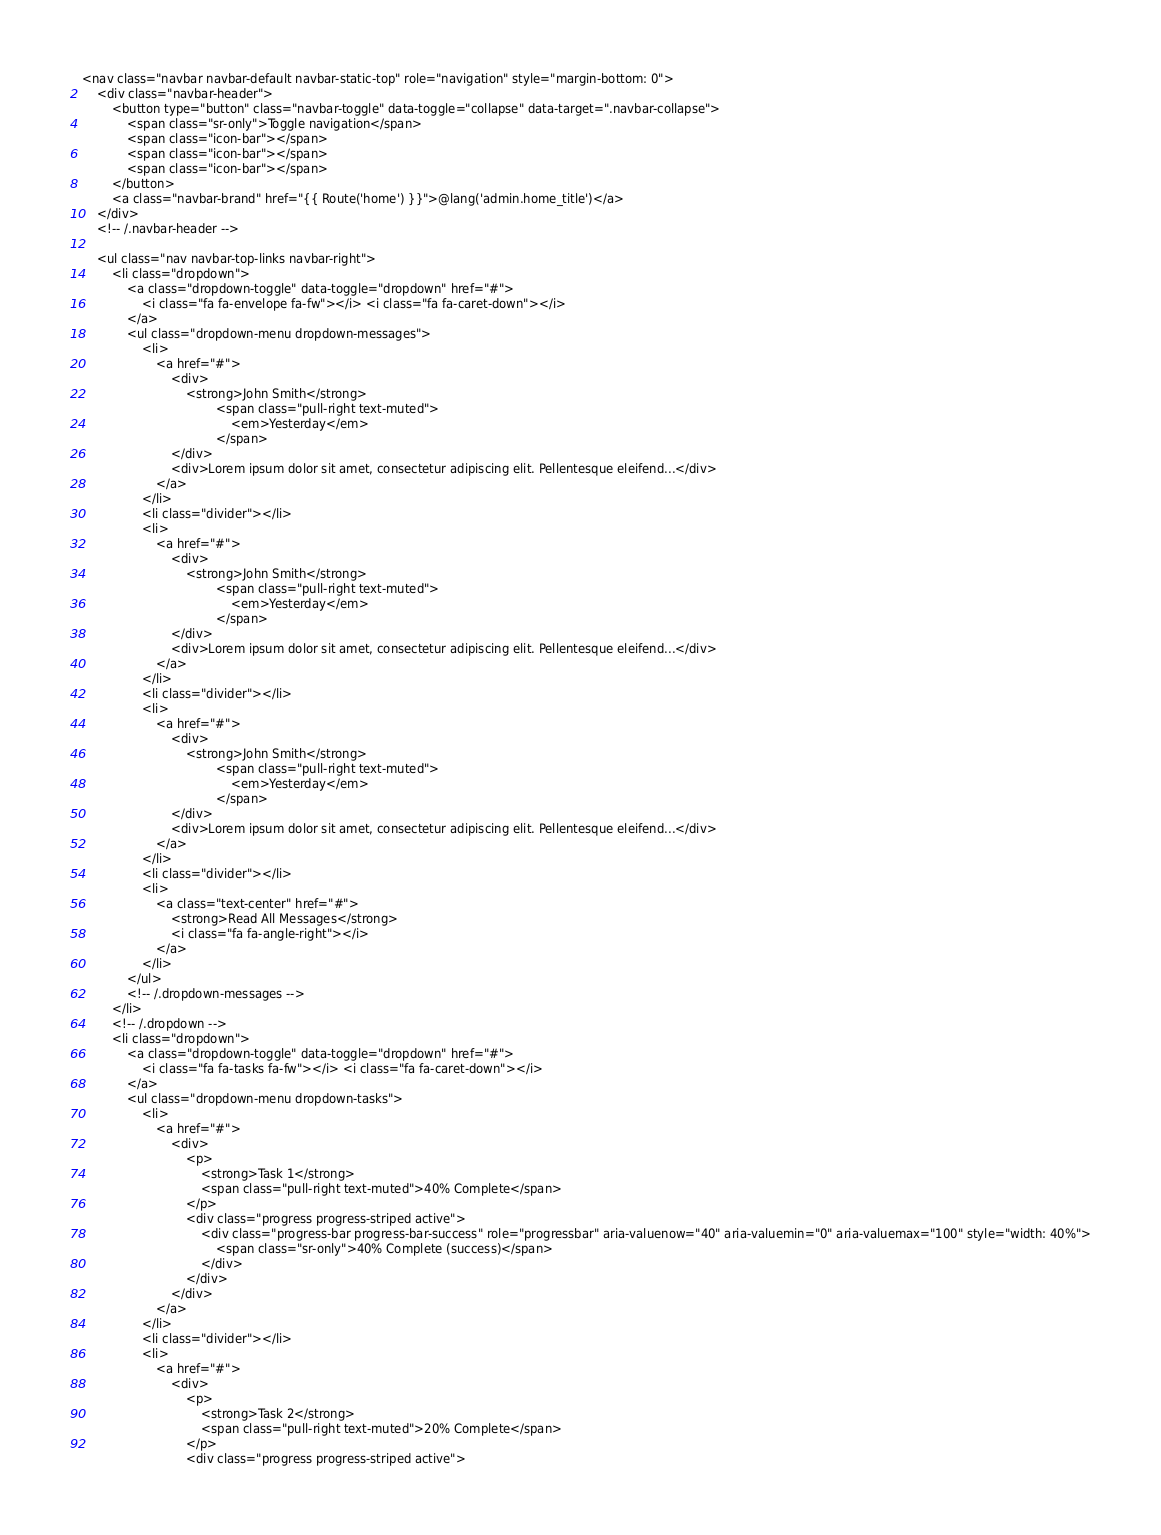<code> <loc_0><loc_0><loc_500><loc_500><_PHP_><nav class="navbar navbar-default navbar-static-top" role="navigation" style="margin-bottom: 0">
    <div class="navbar-header">
        <button type="button" class="navbar-toggle" data-toggle="collapse" data-target=".navbar-collapse">
            <span class="sr-only">Toggle navigation</span>
            <span class="icon-bar"></span>
            <span class="icon-bar"></span>
            <span class="icon-bar"></span>
        </button>
        <a class="navbar-brand" href="{{ Route('home') }}">@lang('admin.home_title')</a>
    </div>
    <!-- /.navbar-header -->

    <ul class="nav navbar-top-links navbar-right">
        <li class="dropdown">
            <a class="dropdown-toggle" data-toggle="dropdown" href="#">
                <i class="fa fa-envelope fa-fw"></i> <i class="fa fa-caret-down"></i>
            </a>
            <ul class="dropdown-menu dropdown-messages">
                <li>
                    <a href="#">
                        <div>
                            <strong>John Smith</strong>
                                    <span class="pull-right text-muted">
                                        <em>Yesterday</em>
                                    </span>
                        </div>
                        <div>Lorem ipsum dolor sit amet, consectetur adipiscing elit. Pellentesque eleifend...</div>
                    </a>
                </li>
                <li class="divider"></li>
                <li>
                    <a href="#">
                        <div>
                            <strong>John Smith</strong>
                                    <span class="pull-right text-muted">
                                        <em>Yesterday</em>
                                    </span>
                        </div>
                        <div>Lorem ipsum dolor sit amet, consectetur adipiscing elit. Pellentesque eleifend...</div>
                    </a>
                </li>
                <li class="divider"></li>
                <li>
                    <a href="#">
                        <div>
                            <strong>John Smith</strong>
                                    <span class="pull-right text-muted">
                                        <em>Yesterday</em>
                                    </span>
                        </div>
                        <div>Lorem ipsum dolor sit amet, consectetur adipiscing elit. Pellentesque eleifend...</div>
                    </a>
                </li>
                <li class="divider"></li>
                <li>
                    <a class="text-center" href="#">
                        <strong>Read All Messages</strong>
                        <i class="fa fa-angle-right"></i>
                    </a>
                </li>
            </ul>
            <!-- /.dropdown-messages -->
        </li>
        <!-- /.dropdown -->
        <li class="dropdown">
            <a class="dropdown-toggle" data-toggle="dropdown" href="#">
                <i class="fa fa-tasks fa-fw"></i> <i class="fa fa-caret-down"></i>
            </a>
            <ul class="dropdown-menu dropdown-tasks">
                <li>
                    <a href="#">
                        <div>
                            <p>
                                <strong>Task 1</strong>
                                <span class="pull-right text-muted">40% Complete</span>
                            </p>
                            <div class="progress progress-striped active">
                                <div class="progress-bar progress-bar-success" role="progressbar" aria-valuenow="40" aria-valuemin="0" aria-valuemax="100" style="width: 40%">
                                    <span class="sr-only">40% Complete (success)</span>
                                </div>
                            </div>
                        </div>
                    </a>
                </li>
                <li class="divider"></li>
                <li>
                    <a href="#">
                        <div>
                            <p>
                                <strong>Task 2</strong>
                                <span class="pull-right text-muted">20% Complete</span>
                            </p>
                            <div class="progress progress-striped active"></code> 